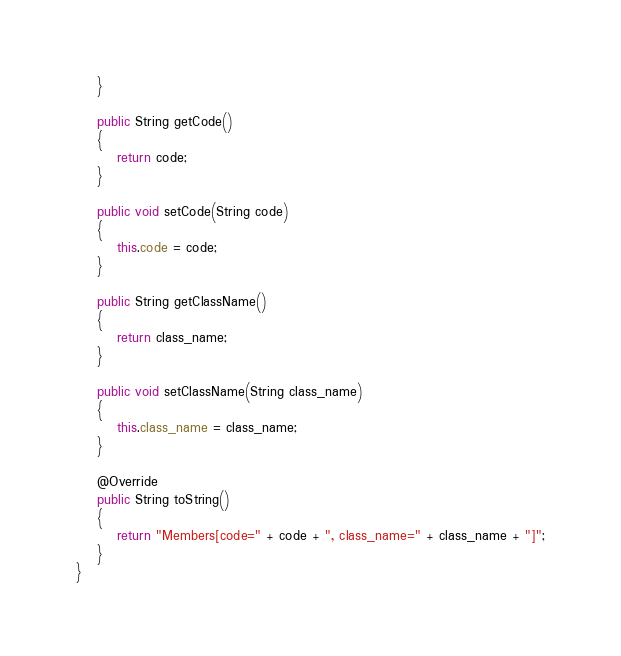<code> <loc_0><loc_0><loc_500><loc_500><_Java_>	}

	public String getCode()
	{
		return code;
	}

	public void setCode(String code)
	{
		this.code = code;
	}
	
	public String getClassName()
	{
		return class_name;
	}

	public void setClassName(String class_name)
	{
		this.class_name = class_name;
	}

	@Override
	public String toString()
	{
		return "Members[code=" + code + ", class_name=" + class_name + "]";
	}
}</code> 